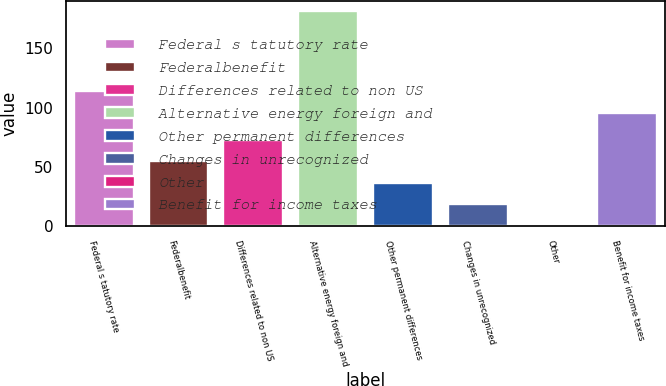Convert chart. <chart><loc_0><loc_0><loc_500><loc_500><bar_chart><fcel>Federal s tatutory rate<fcel>Federalbenefit<fcel>Differences related to non US<fcel>Alternative energy foreign and<fcel>Other permanent differences<fcel>Changes in unrecognized<fcel>Other<fcel>Benefit for income taxes<nl><fcel>113.71<fcel>54.53<fcel>72.64<fcel>181.3<fcel>36.42<fcel>18.31<fcel>0.2<fcel>95.6<nl></chart> 